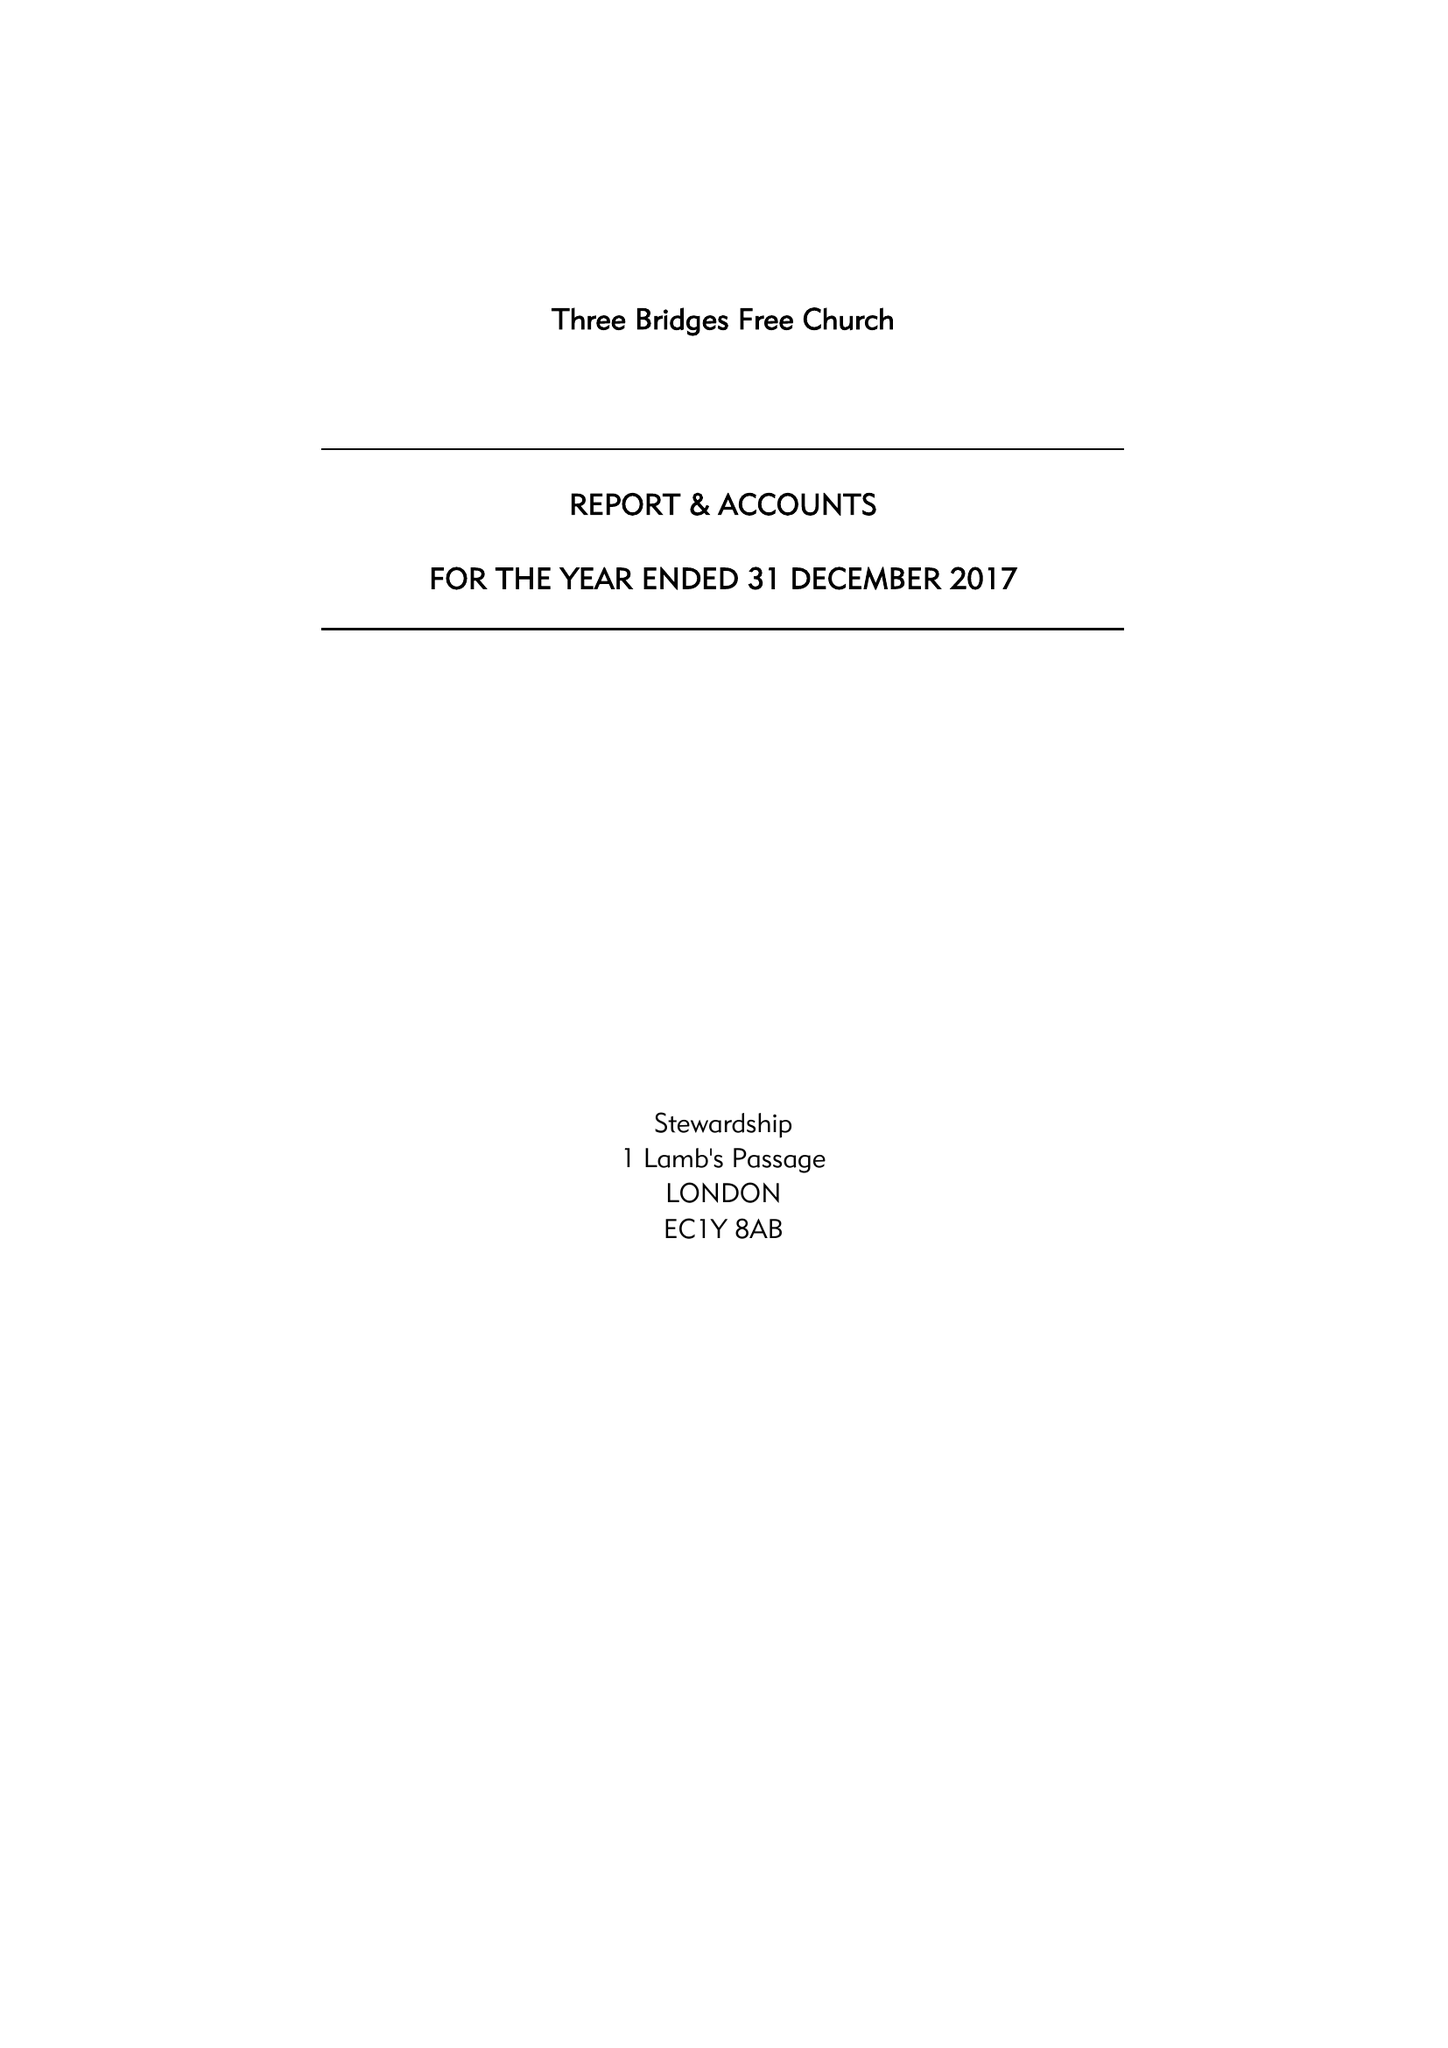What is the value for the charity_name?
Answer the question using a single word or phrase. Three Bridges Free Church 